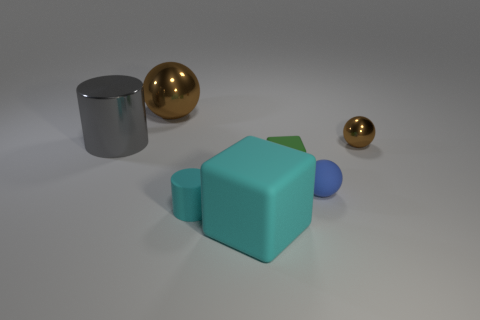Subtract all metal balls. How many balls are left? 1 Add 1 big gray shiny objects. How many objects exist? 8 Subtract all balls. How many objects are left? 4 Subtract 0 cyan balls. How many objects are left? 7 Subtract all tiny metallic cylinders. Subtract all large cyan rubber cubes. How many objects are left? 6 Add 2 small rubber cylinders. How many small rubber cylinders are left? 3 Add 3 big cyan blocks. How many big cyan blocks exist? 4 